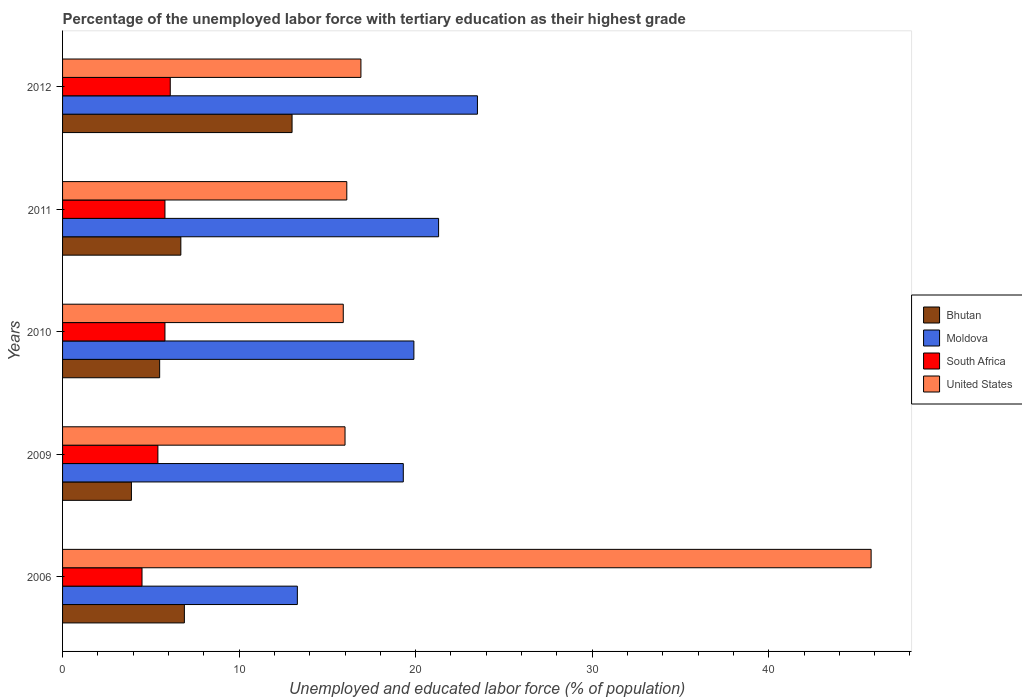How many different coloured bars are there?
Provide a short and direct response. 4. How many groups of bars are there?
Make the answer very short. 5. Are the number of bars per tick equal to the number of legend labels?
Your answer should be very brief. Yes. How many bars are there on the 1st tick from the top?
Offer a very short reply. 4. How many bars are there on the 1st tick from the bottom?
Your answer should be compact. 4. What is the label of the 5th group of bars from the top?
Keep it short and to the point. 2006. In how many cases, is the number of bars for a given year not equal to the number of legend labels?
Keep it short and to the point. 0. Across all years, what is the maximum percentage of the unemployed labor force with tertiary education in United States?
Make the answer very short. 45.8. In which year was the percentage of the unemployed labor force with tertiary education in United States minimum?
Offer a terse response. 2010. What is the total percentage of the unemployed labor force with tertiary education in Bhutan in the graph?
Provide a succinct answer. 36. What is the difference between the percentage of the unemployed labor force with tertiary education in United States in 2009 and that in 2010?
Your answer should be compact. 0.1. What is the difference between the percentage of the unemployed labor force with tertiary education in Bhutan in 2010 and the percentage of the unemployed labor force with tertiary education in Moldova in 2011?
Give a very brief answer. -15.8. In the year 2009, what is the difference between the percentage of the unemployed labor force with tertiary education in South Africa and percentage of the unemployed labor force with tertiary education in United States?
Provide a succinct answer. -10.6. What is the ratio of the percentage of the unemployed labor force with tertiary education in Bhutan in 2006 to that in 2010?
Offer a terse response. 1.25. Is the difference between the percentage of the unemployed labor force with tertiary education in South Africa in 2010 and 2011 greater than the difference between the percentage of the unemployed labor force with tertiary education in United States in 2010 and 2011?
Your answer should be compact. Yes. What is the difference between the highest and the second highest percentage of the unemployed labor force with tertiary education in Moldova?
Your answer should be compact. 2.2. What is the difference between the highest and the lowest percentage of the unemployed labor force with tertiary education in United States?
Make the answer very short. 29.9. What does the 2nd bar from the top in 2006 represents?
Offer a terse response. South Africa. What does the 4th bar from the bottom in 2009 represents?
Make the answer very short. United States. How many years are there in the graph?
Provide a short and direct response. 5. Does the graph contain any zero values?
Your response must be concise. No. Does the graph contain grids?
Ensure brevity in your answer.  No. How many legend labels are there?
Keep it short and to the point. 4. What is the title of the graph?
Offer a very short reply. Percentage of the unemployed labor force with tertiary education as their highest grade. Does "Cabo Verde" appear as one of the legend labels in the graph?
Your response must be concise. No. What is the label or title of the X-axis?
Your response must be concise. Unemployed and educated labor force (% of population). What is the label or title of the Y-axis?
Provide a succinct answer. Years. What is the Unemployed and educated labor force (% of population) of Bhutan in 2006?
Your response must be concise. 6.9. What is the Unemployed and educated labor force (% of population) in Moldova in 2006?
Your response must be concise. 13.3. What is the Unemployed and educated labor force (% of population) in South Africa in 2006?
Give a very brief answer. 4.5. What is the Unemployed and educated labor force (% of population) of United States in 2006?
Make the answer very short. 45.8. What is the Unemployed and educated labor force (% of population) of Bhutan in 2009?
Offer a terse response. 3.9. What is the Unemployed and educated labor force (% of population) in Moldova in 2009?
Ensure brevity in your answer.  19.3. What is the Unemployed and educated labor force (% of population) of South Africa in 2009?
Provide a short and direct response. 5.4. What is the Unemployed and educated labor force (% of population) of United States in 2009?
Your answer should be very brief. 16. What is the Unemployed and educated labor force (% of population) in Moldova in 2010?
Make the answer very short. 19.9. What is the Unemployed and educated labor force (% of population) of South Africa in 2010?
Provide a succinct answer. 5.8. What is the Unemployed and educated labor force (% of population) of United States in 2010?
Provide a short and direct response. 15.9. What is the Unemployed and educated labor force (% of population) of Bhutan in 2011?
Offer a very short reply. 6.7. What is the Unemployed and educated labor force (% of population) of Moldova in 2011?
Make the answer very short. 21.3. What is the Unemployed and educated labor force (% of population) in South Africa in 2011?
Provide a short and direct response. 5.8. What is the Unemployed and educated labor force (% of population) in United States in 2011?
Provide a short and direct response. 16.1. What is the Unemployed and educated labor force (% of population) in Bhutan in 2012?
Provide a succinct answer. 13. What is the Unemployed and educated labor force (% of population) of South Africa in 2012?
Provide a short and direct response. 6.1. What is the Unemployed and educated labor force (% of population) in United States in 2012?
Offer a terse response. 16.9. Across all years, what is the maximum Unemployed and educated labor force (% of population) in Moldova?
Offer a very short reply. 23.5. Across all years, what is the maximum Unemployed and educated labor force (% of population) of South Africa?
Offer a terse response. 6.1. Across all years, what is the maximum Unemployed and educated labor force (% of population) of United States?
Your response must be concise. 45.8. Across all years, what is the minimum Unemployed and educated labor force (% of population) in Bhutan?
Offer a very short reply. 3.9. Across all years, what is the minimum Unemployed and educated labor force (% of population) of Moldova?
Provide a short and direct response. 13.3. Across all years, what is the minimum Unemployed and educated labor force (% of population) of United States?
Keep it short and to the point. 15.9. What is the total Unemployed and educated labor force (% of population) in Bhutan in the graph?
Offer a very short reply. 36. What is the total Unemployed and educated labor force (% of population) in Moldova in the graph?
Your response must be concise. 97.3. What is the total Unemployed and educated labor force (% of population) in South Africa in the graph?
Ensure brevity in your answer.  27.6. What is the total Unemployed and educated labor force (% of population) of United States in the graph?
Offer a terse response. 110.7. What is the difference between the Unemployed and educated labor force (% of population) in United States in 2006 and that in 2009?
Provide a short and direct response. 29.8. What is the difference between the Unemployed and educated labor force (% of population) in Bhutan in 2006 and that in 2010?
Offer a terse response. 1.4. What is the difference between the Unemployed and educated labor force (% of population) of United States in 2006 and that in 2010?
Provide a short and direct response. 29.9. What is the difference between the Unemployed and educated labor force (% of population) of Bhutan in 2006 and that in 2011?
Give a very brief answer. 0.2. What is the difference between the Unemployed and educated labor force (% of population) of Moldova in 2006 and that in 2011?
Your answer should be compact. -8. What is the difference between the Unemployed and educated labor force (% of population) in United States in 2006 and that in 2011?
Provide a succinct answer. 29.7. What is the difference between the Unemployed and educated labor force (% of population) in Moldova in 2006 and that in 2012?
Your answer should be compact. -10.2. What is the difference between the Unemployed and educated labor force (% of population) of South Africa in 2006 and that in 2012?
Your answer should be compact. -1.6. What is the difference between the Unemployed and educated labor force (% of population) of United States in 2006 and that in 2012?
Ensure brevity in your answer.  28.9. What is the difference between the Unemployed and educated labor force (% of population) in Bhutan in 2009 and that in 2010?
Provide a short and direct response. -1.6. What is the difference between the Unemployed and educated labor force (% of population) of South Africa in 2009 and that in 2010?
Provide a succinct answer. -0.4. What is the difference between the Unemployed and educated labor force (% of population) of United States in 2009 and that in 2010?
Offer a terse response. 0.1. What is the difference between the Unemployed and educated labor force (% of population) of Bhutan in 2009 and that in 2011?
Offer a terse response. -2.8. What is the difference between the Unemployed and educated labor force (% of population) in Moldova in 2009 and that in 2011?
Make the answer very short. -2. What is the difference between the Unemployed and educated labor force (% of population) in South Africa in 2009 and that in 2011?
Offer a very short reply. -0.4. What is the difference between the Unemployed and educated labor force (% of population) of South Africa in 2009 and that in 2012?
Ensure brevity in your answer.  -0.7. What is the difference between the Unemployed and educated labor force (% of population) in United States in 2009 and that in 2012?
Your answer should be compact. -0.9. What is the difference between the Unemployed and educated labor force (% of population) of Bhutan in 2010 and that in 2011?
Offer a terse response. -1.2. What is the difference between the Unemployed and educated labor force (% of population) in Moldova in 2010 and that in 2011?
Ensure brevity in your answer.  -1.4. What is the difference between the Unemployed and educated labor force (% of population) in Moldova in 2010 and that in 2012?
Offer a terse response. -3.6. What is the difference between the Unemployed and educated labor force (% of population) in Bhutan in 2011 and that in 2012?
Keep it short and to the point. -6.3. What is the difference between the Unemployed and educated labor force (% of population) of Moldova in 2011 and that in 2012?
Give a very brief answer. -2.2. What is the difference between the Unemployed and educated labor force (% of population) in United States in 2011 and that in 2012?
Make the answer very short. -0.8. What is the difference between the Unemployed and educated labor force (% of population) in Bhutan in 2006 and the Unemployed and educated labor force (% of population) in United States in 2009?
Ensure brevity in your answer.  -9.1. What is the difference between the Unemployed and educated labor force (% of population) of Moldova in 2006 and the Unemployed and educated labor force (% of population) of United States in 2009?
Provide a short and direct response. -2.7. What is the difference between the Unemployed and educated labor force (% of population) in Bhutan in 2006 and the Unemployed and educated labor force (% of population) in United States in 2010?
Make the answer very short. -9. What is the difference between the Unemployed and educated labor force (% of population) in Moldova in 2006 and the Unemployed and educated labor force (% of population) in United States in 2010?
Make the answer very short. -2.6. What is the difference between the Unemployed and educated labor force (% of population) of South Africa in 2006 and the Unemployed and educated labor force (% of population) of United States in 2010?
Give a very brief answer. -11.4. What is the difference between the Unemployed and educated labor force (% of population) of Bhutan in 2006 and the Unemployed and educated labor force (% of population) of Moldova in 2011?
Give a very brief answer. -14.4. What is the difference between the Unemployed and educated labor force (% of population) of South Africa in 2006 and the Unemployed and educated labor force (% of population) of United States in 2011?
Provide a short and direct response. -11.6. What is the difference between the Unemployed and educated labor force (% of population) in Bhutan in 2006 and the Unemployed and educated labor force (% of population) in Moldova in 2012?
Provide a short and direct response. -16.6. What is the difference between the Unemployed and educated labor force (% of population) of Bhutan in 2006 and the Unemployed and educated labor force (% of population) of United States in 2012?
Provide a short and direct response. -10. What is the difference between the Unemployed and educated labor force (% of population) of Moldova in 2006 and the Unemployed and educated labor force (% of population) of South Africa in 2012?
Offer a terse response. 7.2. What is the difference between the Unemployed and educated labor force (% of population) of South Africa in 2006 and the Unemployed and educated labor force (% of population) of United States in 2012?
Offer a very short reply. -12.4. What is the difference between the Unemployed and educated labor force (% of population) of Bhutan in 2009 and the Unemployed and educated labor force (% of population) of Moldova in 2010?
Offer a terse response. -16. What is the difference between the Unemployed and educated labor force (% of population) of Bhutan in 2009 and the Unemployed and educated labor force (% of population) of South Africa in 2010?
Provide a short and direct response. -1.9. What is the difference between the Unemployed and educated labor force (% of population) in Moldova in 2009 and the Unemployed and educated labor force (% of population) in United States in 2010?
Offer a terse response. 3.4. What is the difference between the Unemployed and educated labor force (% of population) of Bhutan in 2009 and the Unemployed and educated labor force (% of population) of Moldova in 2011?
Keep it short and to the point. -17.4. What is the difference between the Unemployed and educated labor force (% of population) of Bhutan in 2009 and the Unemployed and educated labor force (% of population) of United States in 2011?
Offer a terse response. -12.2. What is the difference between the Unemployed and educated labor force (% of population) in Moldova in 2009 and the Unemployed and educated labor force (% of population) in South Africa in 2011?
Ensure brevity in your answer.  13.5. What is the difference between the Unemployed and educated labor force (% of population) in Moldova in 2009 and the Unemployed and educated labor force (% of population) in United States in 2011?
Give a very brief answer. 3.2. What is the difference between the Unemployed and educated labor force (% of population) of Bhutan in 2009 and the Unemployed and educated labor force (% of population) of Moldova in 2012?
Your answer should be very brief. -19.6. What is the difference between the Unemployed and educated labor force (% of population) of Bhutan in 2009 and the Unemployed and educated labor force (% of population) of South Africa in 2012?
Your answer should be very brief. -2.2. What is the difference between the Unemployed and educated labor force (% of population) in Bhutan in 2009 and the Unemployed and educated labor force (% of population) in United States in 2012?
Your answer should be very brief. -13. What is the difference between the Unemployed and educated labor force (% of population) of Moldova in 2009 and the Unemployed and educated labor force (% of population) of United States in 2012?
Provide a short and direct response. 2.4. What is the difference between the Unemployed and educated labor force (% of population) of South Africa in 2009 and the Unemployed and educated labor force (% of population) of United States in 2012?
Your answer should be compact. -11.5. What is the difference between the Unemployed and educated labor force (% of population) of Bhutan in 2010 and the Unemployed and educated labor force (% of population) of Moldova in 2011?
Provide a short and direct response. -15.8. What is the difference between the Unemployed and educated labor force (% of population) of Bhutan in 2010 and the Unemployed and educated labor force (% of population) of South Africa in 2011?
Your response must be concise. -0.3. What is the difference between the Unemployed and educated labor force (% of population) of Moldova in 2010 and the Unemployed and educated labor force (% of population) of South Africa in 2011?
Offer a very short reply. 14.1. What is the difference between the Unemployed and educated labor force (% of population) in Moldova in 2010 and the Unemployed and educated labor force (% of population) in United States in 2011?
Offer a very short reply. 3.8. What is the difference between the Unemployed and educated labor force (% of population) of Bhutan in 2010 and the Unemployed and educated labor force (% of population) of Moldova in 2012?
Keep it short and to the point. -18. What is the difference between the Unemployed and educated labor force (% of population) of Bhutan in 2010 and the Unemployed and educated labor force (% of population) of South Africa in 2012?
Your answer should be very brief. -0.6. What is the difference between the Unemployed and educated labor force (% of population) in Bhutan in 2010 and the Unemployed and educated labor force (% of population) in United States in 2012?
Keep it short and to the point. -11.4. What is the difference between the Unemployed and educated labor force (% of population) of Moldova in 2010 and the Unemployed and educated labor force (% of population) of United States in 2012?
Offer a terse response. 3. What is the difference between the Unemployed and educated labor force (% of population) in South Africa in 2010 and the Unemployed and educated labor force (% of population) in United States in 2012?
Offer a very short reply. -11.1. What is the difference between the Unemployed and educated labor force (% of population) in Bhutan in 2011 and the Unemployed and educated labor force (% of population) in Moldova in 2012?
Keep it short and to the point. -16.8. What is the difference between the Unemployed and educated labor force (% of population) of Moldova in 2011 and the Unemployed and educated labor force (% of population) of South Africa in 2012?
Provide a succinct answer. 15.2. What is the difference between the Unemployed and educated labor force (% of population) of Moldova in 2011 and the Unemployed and educated labor force (% of population) of United States in 2012?
Offer a terse response. 4.4. What is the difference between the Unemployed and educated labor force (% of population) in South Africa in 2011 and the Unemployed and educated labor force (% of population) in United States in 2012?
Offer a very short reply. -11.1. What is the average Unemployed and educated labor force (% of population) in Moldova per year?
Make the answer very short. 19.46. What is the average Unemployed and educated labor force (% of population) in South Africa per year?
Offer a terse response. 5.52. What is the average Unemployed and educated labor force (% of population) in United States per year?
Keep it short and to the point. 22.14. In the year 2006, what is the difference between the Unemployed and educated labor force (% of population) in Bhutan and Unemployed and educated labor force (% of population) in South Africa?
Your answer should be very brief. 2.4. In the year 2006, what is the difference between the Unemployed and educated labor force (% of population) in Bhutan and Unemployed and educated labor force (% of population) in United States?
Your answer should be very brief. -38.9. In the year 2006, what is the difference between the Unemployed and educated labor force (% of population) in Moldova and Unemployed and educated labor force (% of population) in United States?
Your answer should be very brief. -32.5. In the year 2006, what is the difference between the Unemployed and educated labor force (% of population) of South Africa and Unemployed and educated labor force (% of population) of United States?
Give a very brief answer. -41.3. In the year 2009, what is the difference between the Unemployed and educated labor force (% of population) in Bhutan and Unemployed and educated labor force (% of population) in Moldova?
Provide a short and direct response. -15.4. In the year 2009, what is the difference between the Unemployed and educated labor force (% of population) of Bhutan and Unemployed and educated labor force (% of population) of South Africa?
Provide a succinct answer. -1.5. In the year 2009, what is the difference between the Unemployed and educated labor force (% of population) in Bhutan and Unemployed and educated labor force (% of population) in United States?
Keep it short and to the point. -12.1. In the year 2010, what is the difference between the Unemployed and educated labor force (% of population) in Bhutan and Unemployed and educated labor force (% of population) in Moldova?
Offer a very short reply. -14.4. In the year 2010, what is the difference between the Unemployed and educated labor force (% of population) in Bhutan and Unemployed and educated labor force (% of population) in South Africa?
Provide a short and direct response. -0.3. In the year 2010, what is the difference between the Unemployed and educated labor force (% of population) of Bhutan and Unemployed and educated labor force (% of population) of United States?
Your answer should be compact. -10.4. In the year 2010, what is the difference between the Unemployed and educated labor force (% of population) in Moldova and Unemployed and educated labor force (% of population) in South Africa?
Offer a very short reply. 14.1. In the year 2011, what is the difference between the Unemployed and educated labor force (% of population) of Bhutan and Unemployed and educated labor force (% of population) of Moldova?
Offer a very short reply. -14.6. In the year 2011, what is the difference between the Unemployed and educated labor force (% of population) in Bhutan and Unemployed and educated labor force (% of population) in South Africa?
Offer a terse response. 0.9. In the year 2011, what is the difference between the Unemployed and educated labor force (% of population) of Moldova and Unemployed and educated labor force (% of population) of South Africa?
Give a very brief answer. 15.5. In the year 2011, what is the difference between the Unemployed and educated labor force (% of population) of South Africa and Unemployed and educated labor force (% of population) of United States?
Offer a very short reply. -10.3. In the year 2012, what is the difference between the Unemployed and educated labor force (% of population) in Bhutan and Unemployed and educated labor force (% of population) in South Africa?
Give a very brief answer. 6.9. In the year 2012, what is the difference between the Unemployed and educated labor force (% of population) in Bhutan and Unemployed and educated labor force (% of population) in United States?
Offer a terse response. -3.9. In the year 2012, what is the difference between the Unemployed and educated labor force (% of population) of Moldova and Unemployed and educated labor force (% of population) of United States?
Your response must be concise. 6.6. In the year 2012, what is the difference between the Unemployed and educated labor force (% of population) in South Africa and Unemployed and educated labor force (% of population) in United States?
Your response must be concise. -10.8. What is the ratio of the Unemployed and educated labor force (% of population) of Bhutan in 2006 to that in 2009?
Your answer should be compact. 1.77. What is the ratio of the Unemployed and educated labor force (% of population) in Moldova in 2006 to that in 2009?
Your answer should be compact. 0.69. What is the ratio of the Unemployed and educated labor force (% of population) of South Africa in 2006 to that in 2009?
Your answer should be compact. 0.83. What is the ratio of the Unemployed and educated labor force (% of population) in United States in 2006 to that in 2009?
Provide a succinct answer. 2.86. What is the ratio of the Unemployed and educated labor force (% of population) in Bhutan in 2006 to that in 2010?
Your answer should be very brief. 1.25. What is the ratio of the Unemployed and educated labor force (% of population) in Moldova in 2006 to that in 2010?
Ensure brevity in your answer.  0.67. What is the ratio of the Unemployed and educated labor force (% of population) of South Africa in 2006 to that in 2010?
Give a very brief answer. 0.78. What is the ratio of the Unemployed and educated labor force (% of population) in United States in 2006 to that in 2010?
Your answer should be very brief. 2.88. What is the ratio of the Unemployed and educated labor force (% of population) of Bhutan in 2006 to that in 2011?
Provide a succinct answer. 1.03. What is the ratio of the Unemployed and educated labor force (% of population) in Moldova in 2006 to that in 2011?
Ensure brevity in your answer.  0.62. What is the ratio of the Unemployed and educated labor force (% of population) of South Africa in 2006 to that in 2011?
Provide a short and direct response. 0.78. What is the ratio of the Unemployed and educated labor force (% of population) of United States in 2006 to that in 2011?
Give a very brief answer. 2.84. What is the ratio of the Unemployed and educated labor force (% of population) in Bhutan in 2006 to that in 2012?
Provide a succinct answer. 0.53. What is the ratio of the Unemployed and educated labor force (% of population) in Moldova in 2006 to that in 2012?
Offer a very short reply. 0.57. What is the ratio of the Unemployed and educated labor force (% of population) in South Africa in 2006 to that in 2012?
Offer a terse response. 0.74. What is the ratio of the Unemployed and educated labor force (% of population) of United States in 2006 to that in 2012?
Make the answer very short. 2.71. What is the ratio of the Unemployed and educated labor force (% of population) of Bhutan in 2009 to that in 2010?
Keep it short and to the point. 0.71. What is the ratio of the Unemployed and educated labor force (% of population) of Moldova in 2009 to that in 2010?
Your response must be concise. 0.97. What is the ratio of the Unemployed and educated labor force (% of population) of South Africa in 2009 to that in 2010?
Make the answer very short. 0.93. What is the ratio of the Unemployed and educated labor force (% of population) of United States in 2009 to that in 2010?
Give a very brief answer. 1.01. What is the ratio of the Unemployed and educated labor force (% of population) in Bhutan in 2009 to that in 2011?
Ensure brevity in your answer.  0.58. What is the ratio of the Unemployed and educated labor force (% of population) in Moldova in 2009 to that in 2011?
Give a very brief answer. 0.91. What is the ratio of the Unemployed and educated labor force (% of population) of Bhutan in 2009 to that in 2012?
Ensure brevity in your answer.  0.3. What is the ratio of the Unemployed and educated labor force (% of population) of Moldova in 2009 to that in 2012?
Your response must be concise. 0.82. What is the ratio of the Unemployed and educated labor force (% of population) of South Africa in 2009 to that in 2012?
Your answer should be very brief. 0.89. What is the ratio of the Unemployed and educated labor force (% of population) of United States in 2009 to that in 2012?
Ensure brevity in your answer.  0.95. What is the ratio of the Unemployed and educated labor force (% of population) in Bhutan in 2010 to that in 2011?
Keep it short and to the point. 0.82. What is the ratio of the Unemployed and educated labor force (% of population) in Moldova in 2010 to that in 2011?
Provide a succinct answer. 0.93. What is the ratio of the Unemployed and educated labor force (% of population) of South Africa in 2010 to that in 2011?
Your answer should be compact. 1. What is the ratio of the Unemployed and educated labor force (% of population) in United States in 2010 to that in 2011?
Provide a short and direct response. 0.99. What is the ratio of the Unemployed and educated labor force (% of population) of Bhutan in 2010 to that in 2012?
Your response must be concise. 0.42. What is the ratio of the Unemployed and educated labor force (% of population) of Moldova in 2010 to that in 2012?
Your response must be concise. 0.85. What is the ratio of the Unemployed and educated labor force (% of population) of South Africa in 2010 to that in 2012?
Ensure brevity in your answer.  0.95. What is the ratio of the Unemployed and educated labor force (% of population) in United States in 2010 to that in 2012?
Your response must be concise. 0.94. What is the ratio of the Unemployed and educated labor force (% of population) in Bhutan in 2011 to that in 2012?
Give a very brief answer. 0.52. What is the ratio of the Unemployed and educated labor force (% of population) in Moldova in 2011 to that in 2012?
Your answer should be very brief. 0.91. What is the ratio of the Unemployed and educated labor force (% of population) in South Africa in 2011 to that in 2012?
Keep it short and to the point. 0.95. What is the ratio of the Unemployed and educated labor force (% of population) of United States in 2011 to that in 2012?
Your answer should be compact. 0.95. What is the difference between the highest and the second highest Unemployed and educated labor force (% of population) in Bhutan?
Make the answer very short. 6.1. What is the difference between the highest and the second highest Unemployed and educated labor force (% of population) in Moldova?
Give a very brief answer. 2.2. What is the difference between the highest and the second highest Unemployed and educated labor force (% of population) in United States?
Give a very brief answer. 28.9. What is the difference between the highest and the lowest Unemployed and educated labor force (% of population) of United States?
Keep it short and to the point. 29.9. 